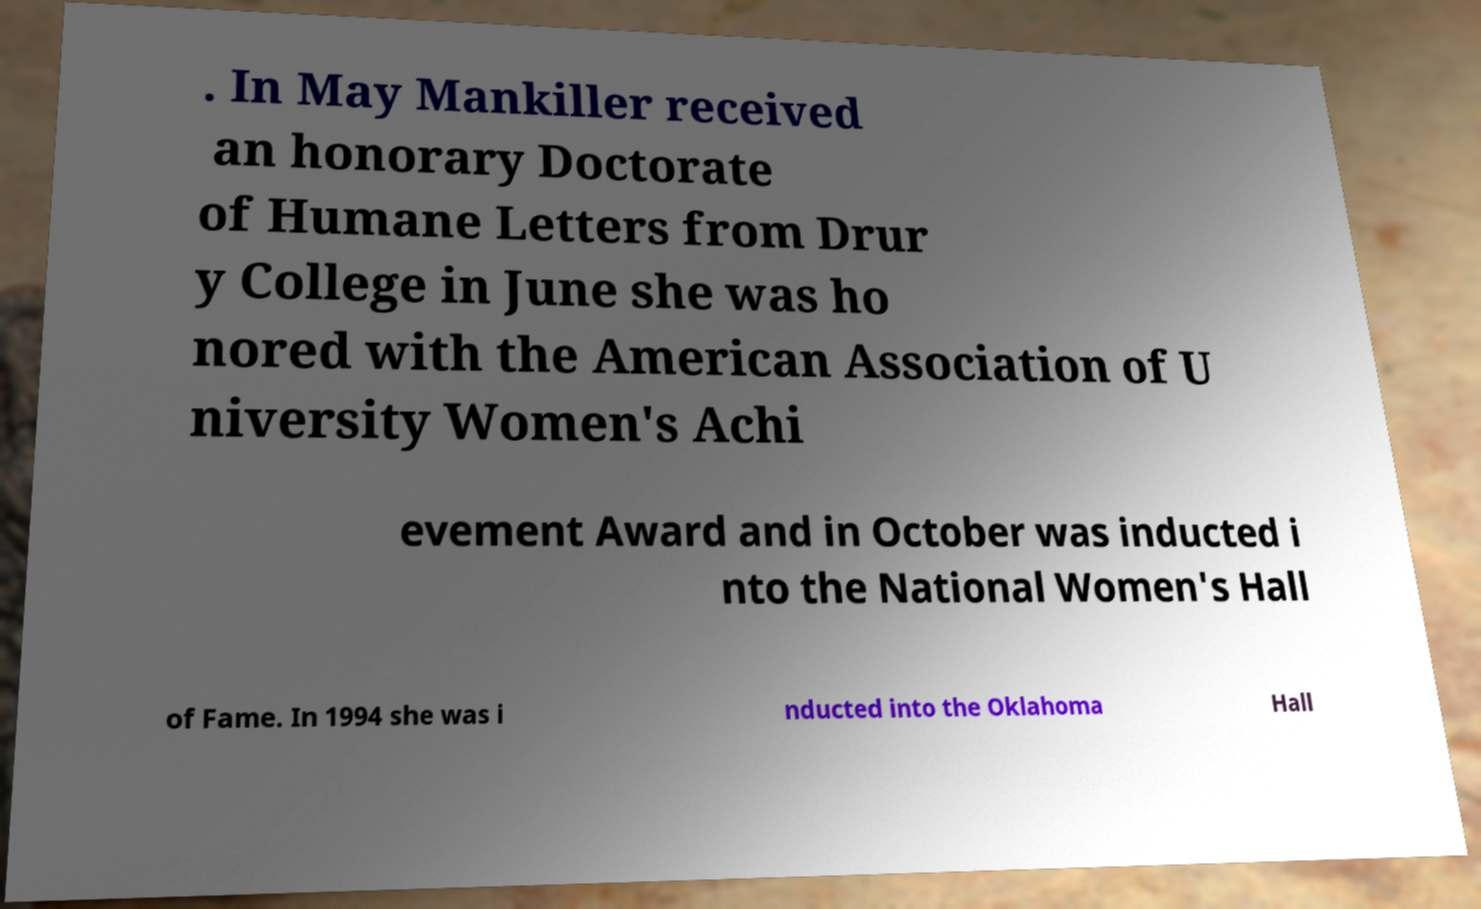Could you extract and type out the text from this image? . In May Mankiller received an honorary Doctorate of Humane Letters from Drur y College in June she was ho nored with the American Association of U niversity Women's Achi evement Award and in October was inducted i nto the National Women's Hall of Fame. In 1994 she was i nducted into the Oklahoma Hall 